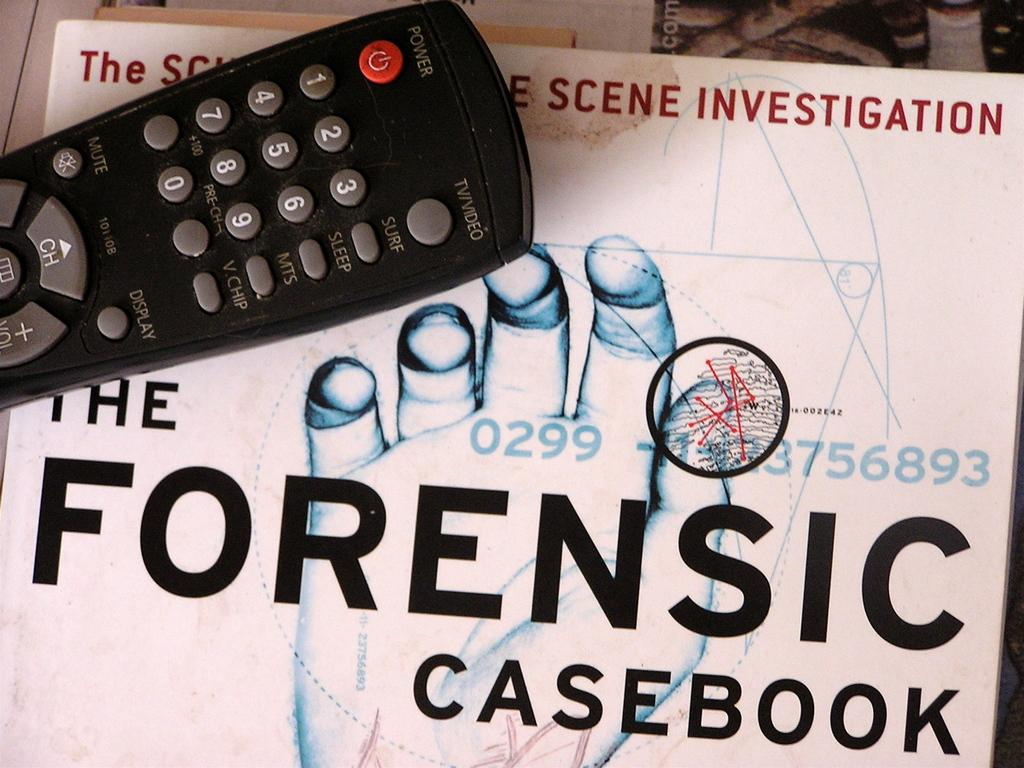Provide a one-sentence caption for the provided image. Remote control sitting on top of title that state the Forensic Casebook. 